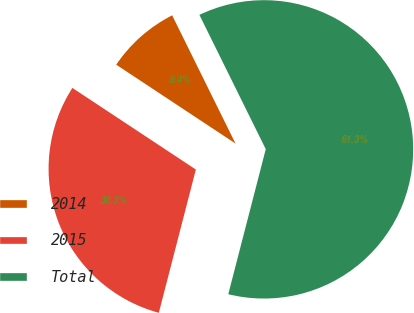<chart> <loc_0><loc_0><loc_500><loc_500><pie_chart><fcel>2014<fcel>2015<fcel>Total<nl><fcel>8.4%<fcel>30.27%<fcel>61.33%<nl></chart> 